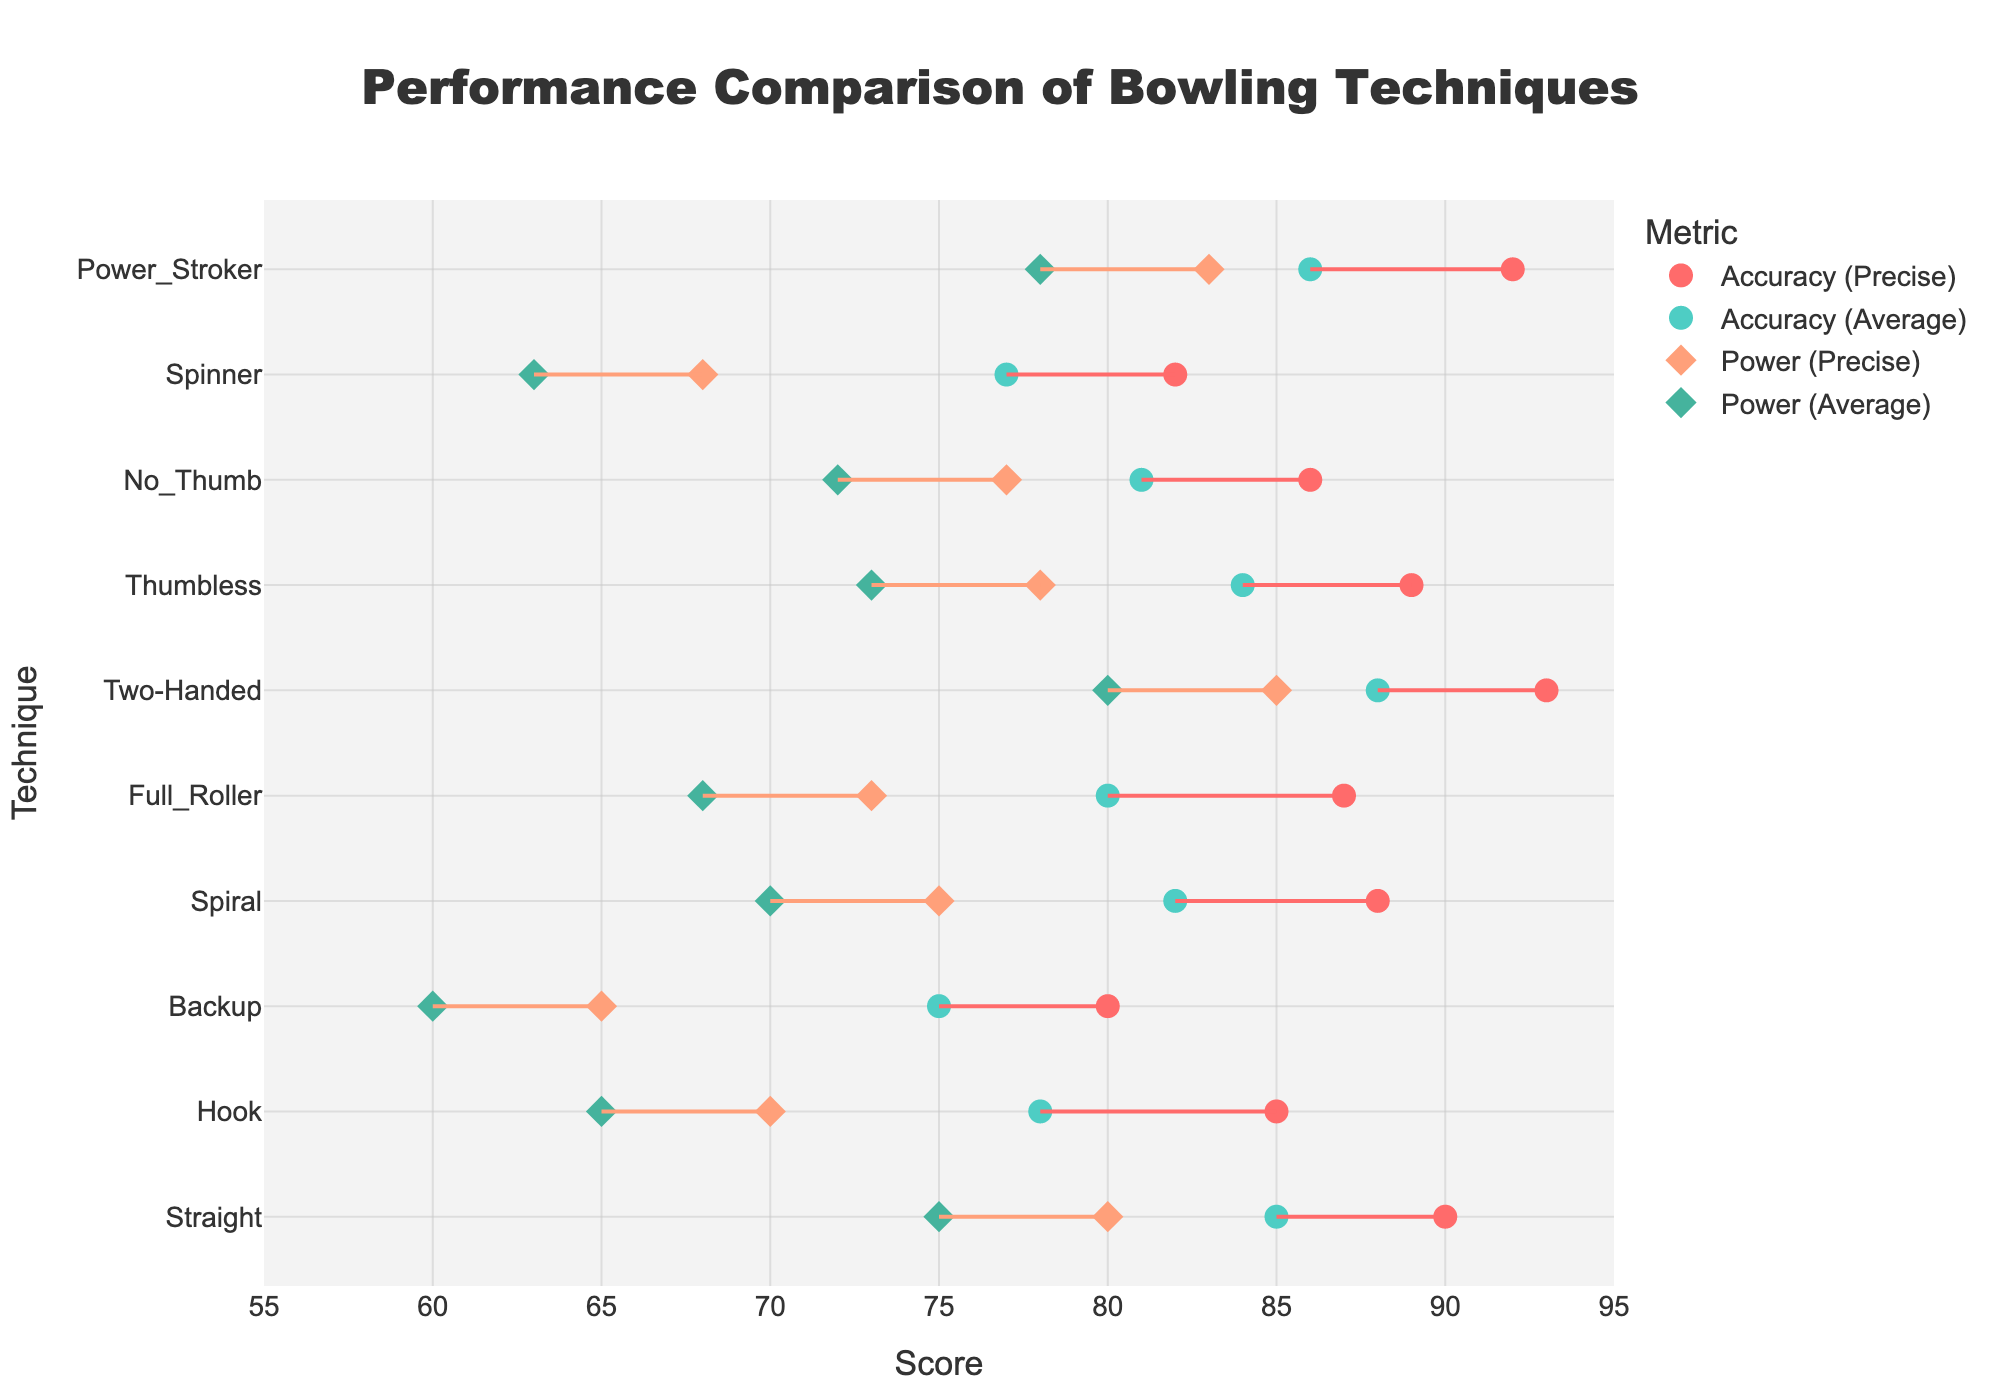which bowling technique has the highest accuracy in precise conditions? Referring to the plot, look for the highest value on the x-axis labeled "Accuracy (Precise)"..
Answer: Two-Handed has the highest accuracy of 93 how many techniques have an average accuracy of 80 or higher? Count the number of horizontal lines (representing bowling techniques) whose 'Accuracy (Average)' marker is at 80 or above on the x-axis.
Answer: 6 techniques what is the difference between the power precise and power average scores for the 'Power_Stroker' technique? Find the 'Power Precise' and 'Power Average' scores for 'Power_Stroker' then subtract the average score from the precise score: 83 - 78 = 5.
Answer: 5 which bowling technique shows the smallest difference between its precise and average accuracy scores? Determine the difference for each technique by subtracting 'Accuracy Average' from 'Accuracy Precise', then find the smallest difference.
Answer: Straight (5) are there any techniques with a higher average power score than their precise power score? Compare the 'Power Precise' and 'Power Average' scores for all techniques.
Answer: No, all precise scores are higher which technique has the highest disparity between precise and average power scores? Calculate the difference between 'Power Precise' and 'Power Average' for all techniques, and identify the maximum.
Answer: Two-Handed (5) calculate the average precise accuracy score for all techniques? Sum all 'Accuracy Precise' scores and divide by the number of techniques: (90 + 85 + 80 + 88 + 87 + 93 + 89 + 86 + 82 + 92) / 10.
Answer: 87.2 which techniques have both precise and average scores (for either power or accuracy) that exceed 80? Identify techniques where all scores ('Accuracy Precise', 'Accuracy Average', 'Power Precise', 'Power Average') are 80 or more.
Answer: Two-Handed and Power_Stroker for the 'Full_Roller' technique, how much higher is the precise accuracy score compared to the precise power score? Calculate the difference between 'Accuracy Precise' (87) and 'Power Precise' (73) for 'Full_Roller': 87 - 73 = 14.
Answer: 14 what is the lowest precise power score among all the techniques? Identify the smallest value in the 'Power Precise' column.
Answer: 65 (Backup) 